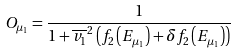<formula> <loc_0><loc_0><loc_500><loc_500>O _ { \mu _ { 1 } } = \frac { 1 } { 1 + \overline { v _ { 1 } } ^ { 2 } \left ( f _ { 2 } \left ( E _ { \mu _ { 1 } } \right ) + \delta f _ { 2 } \left ( E _ { \mu _ { 1 } } \right ) \right ) }</formula> 